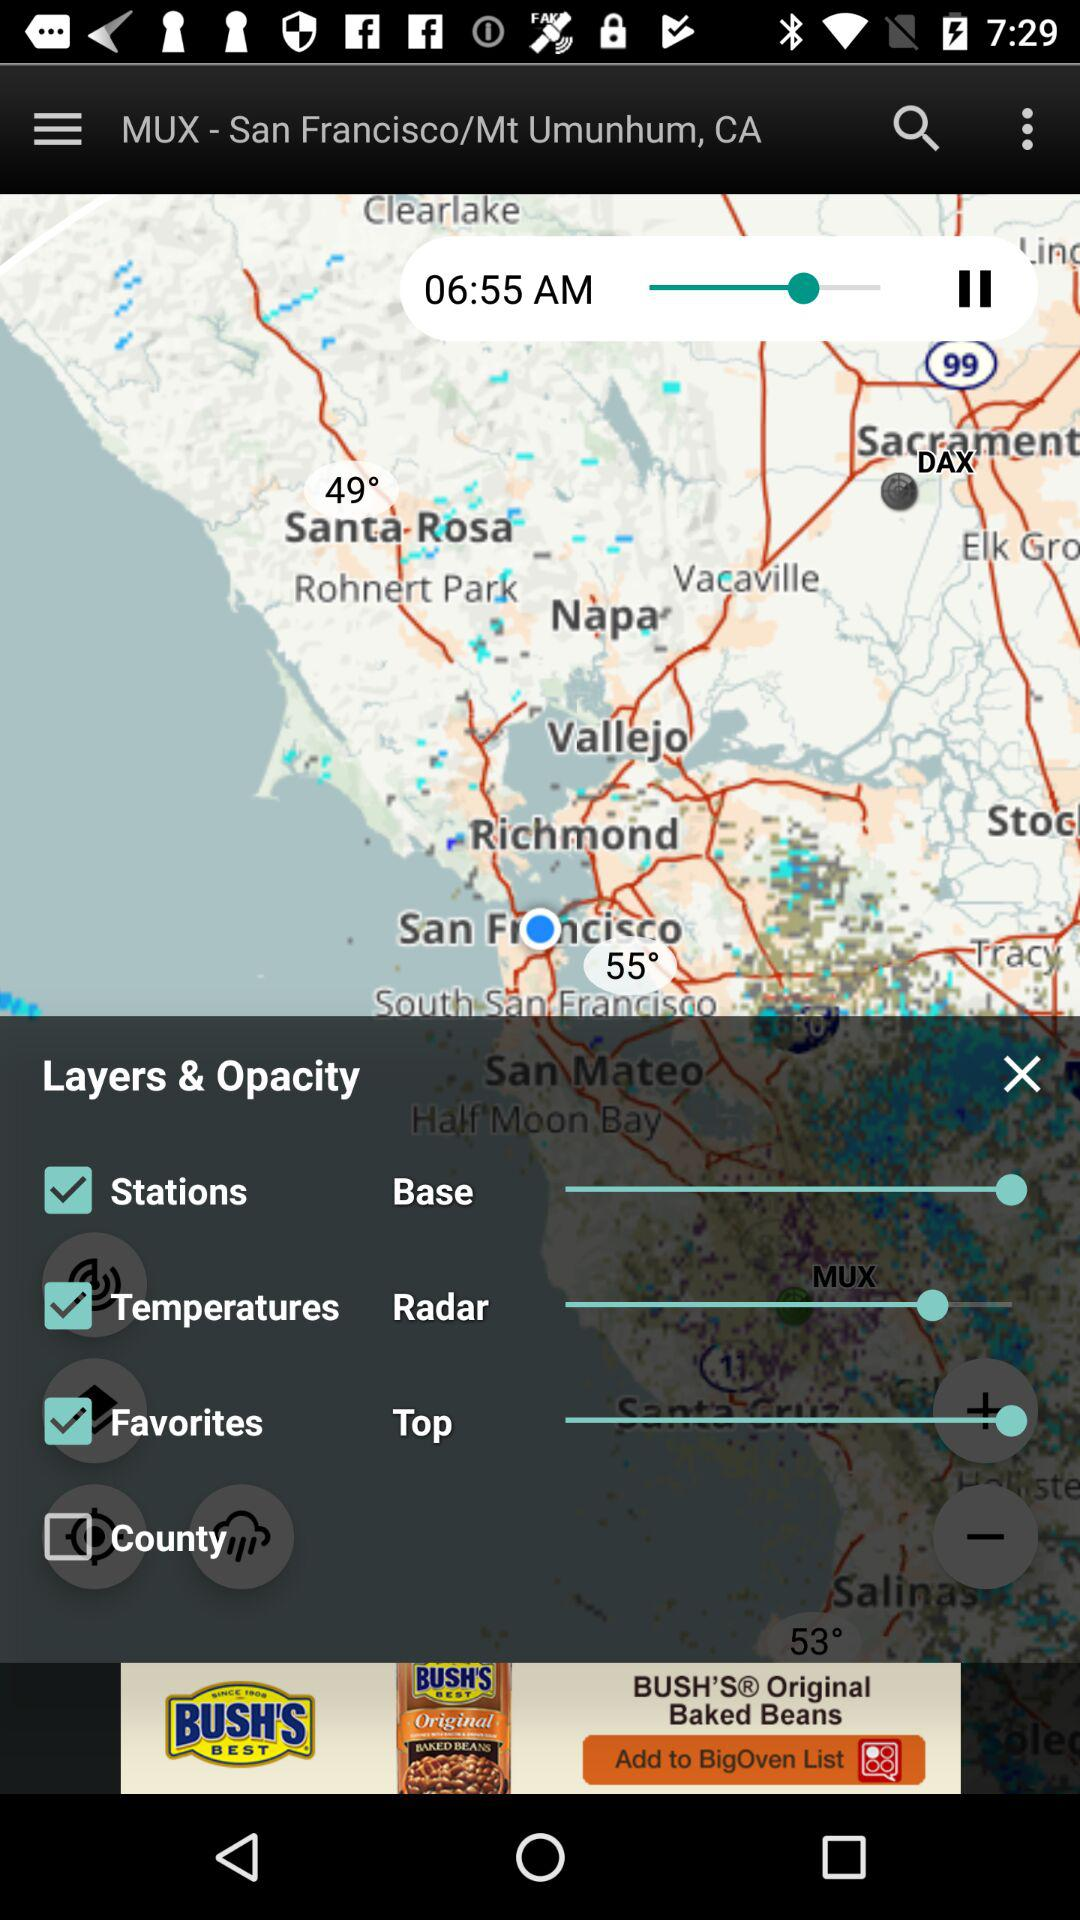What is the status of "Temperatures"? The status is "on". 